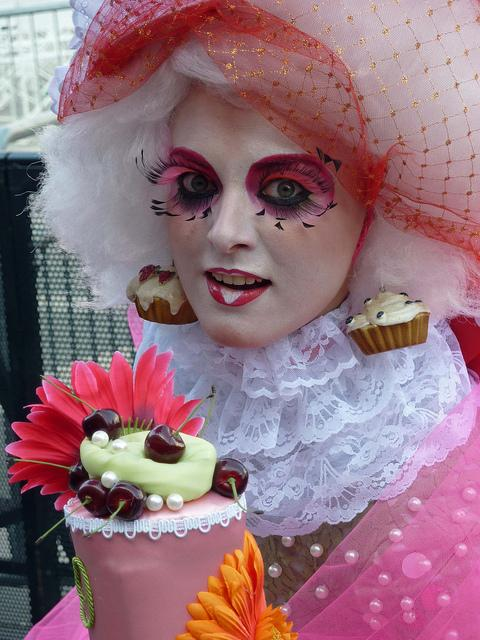What stuff in the photo is edible? Please explain your reasoning. cherry. The cherries look to be real. 